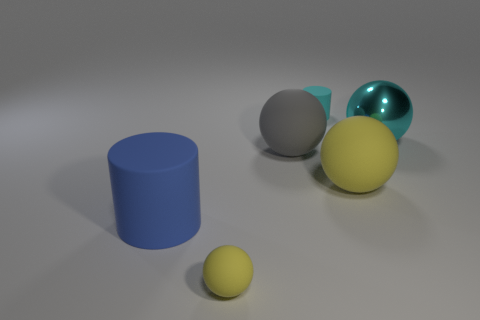There is a tiny rubber object that is behind the large blue cylinder; what is its color?
Keep it short and to the point. Cyan. Are there more things left of the gray matte sphere than tiny gray blocks?
Your response must be concise. Yes. What is the color of the tiny cylinder?
Your response must be concise. Cyan. There is a yellow rubber object to the right of the big gray object in front of the matte cylinder behind the blue thing; what is its shape?
Offer a terse response. Sphere. There is a large sphere that is both to the right of the small cyan object and on the left side of the large shiny thing; what is it made of?
Give a very brief answer. Rubber. There is a tiny object right of the tiny yellow thing that is in front of the tiny cyan cylinder; what shape is it?
Your answer should be compact. Cylinder. Are there any other things of the same color as the small rubber ball?
Your answer should be very brief. Yes. There is a blue cylinder; is its size the same as the yellow thing that is on the right side of the small yellow sphere?
Your answer should be compact. Yes. How many big objects are either cyan matte cylinders or balls?
Provide a short and direct response. 3. Is the number of small blue matte spheres greater than the number of large rubber things?
Provide a succinct answer. No. 